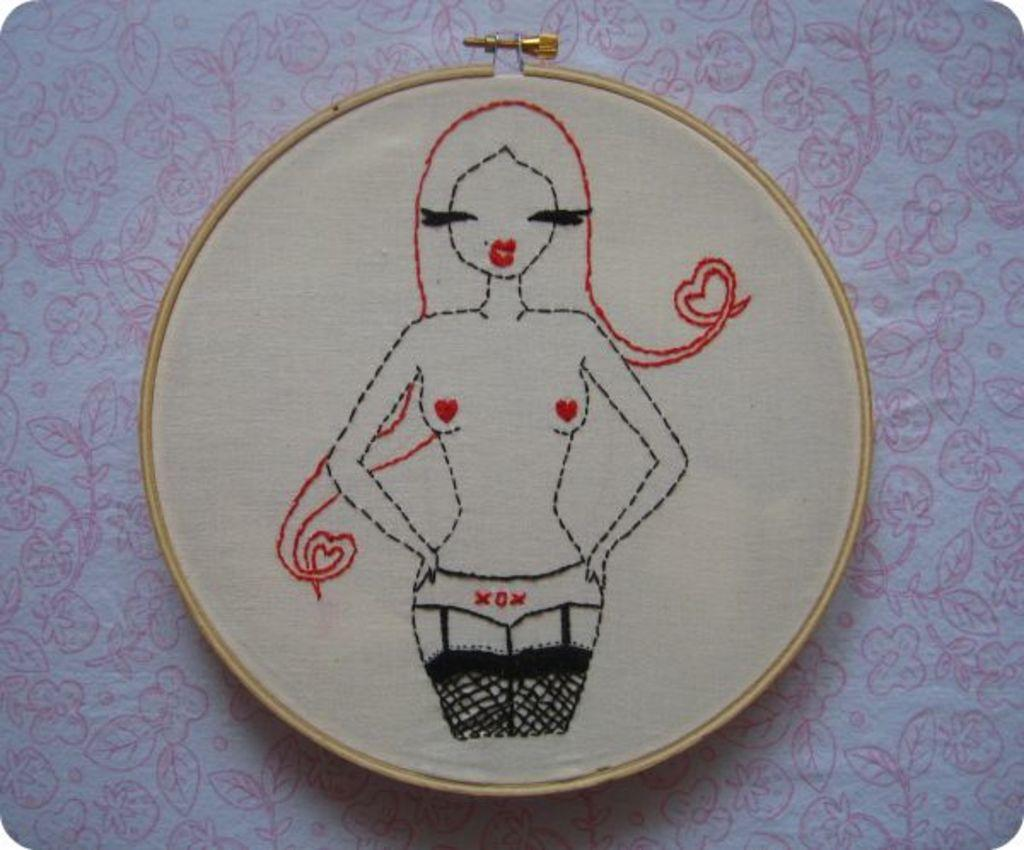What type of produce is hanging from the skirt in the image? There is no skirt or produce present in the image. 